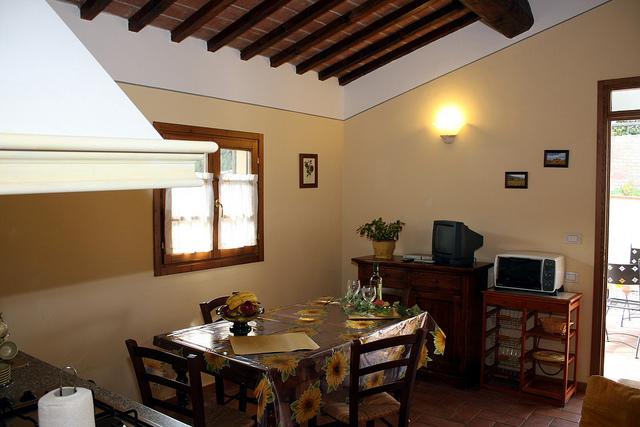Is there food on the table?
Quick response, please. No. Who is in the room?
Concise answer only. No one. Is there a TV in the room?
Quick response, please. Yes. 